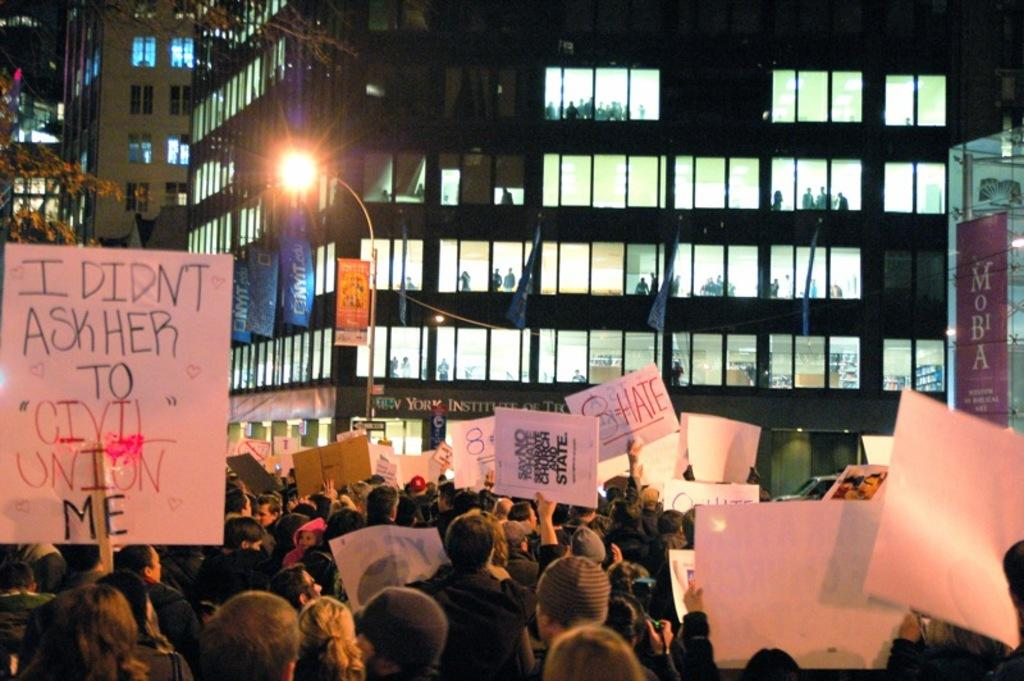What can be seen in the image? There are people, posters, buildings, banners, a street lamp, and a tree on the left side of the image. What type of structures are present in the image? The structures in the image include buildings and a street lamp. What additional items can be seen in the image? There are posters and banners in the image. How would you describe the lighting in the image? The image is slightly dark. How many children are sitting on the seat in the image? There is no seat present in the image, and therefore no children can be seen sitting on it. 